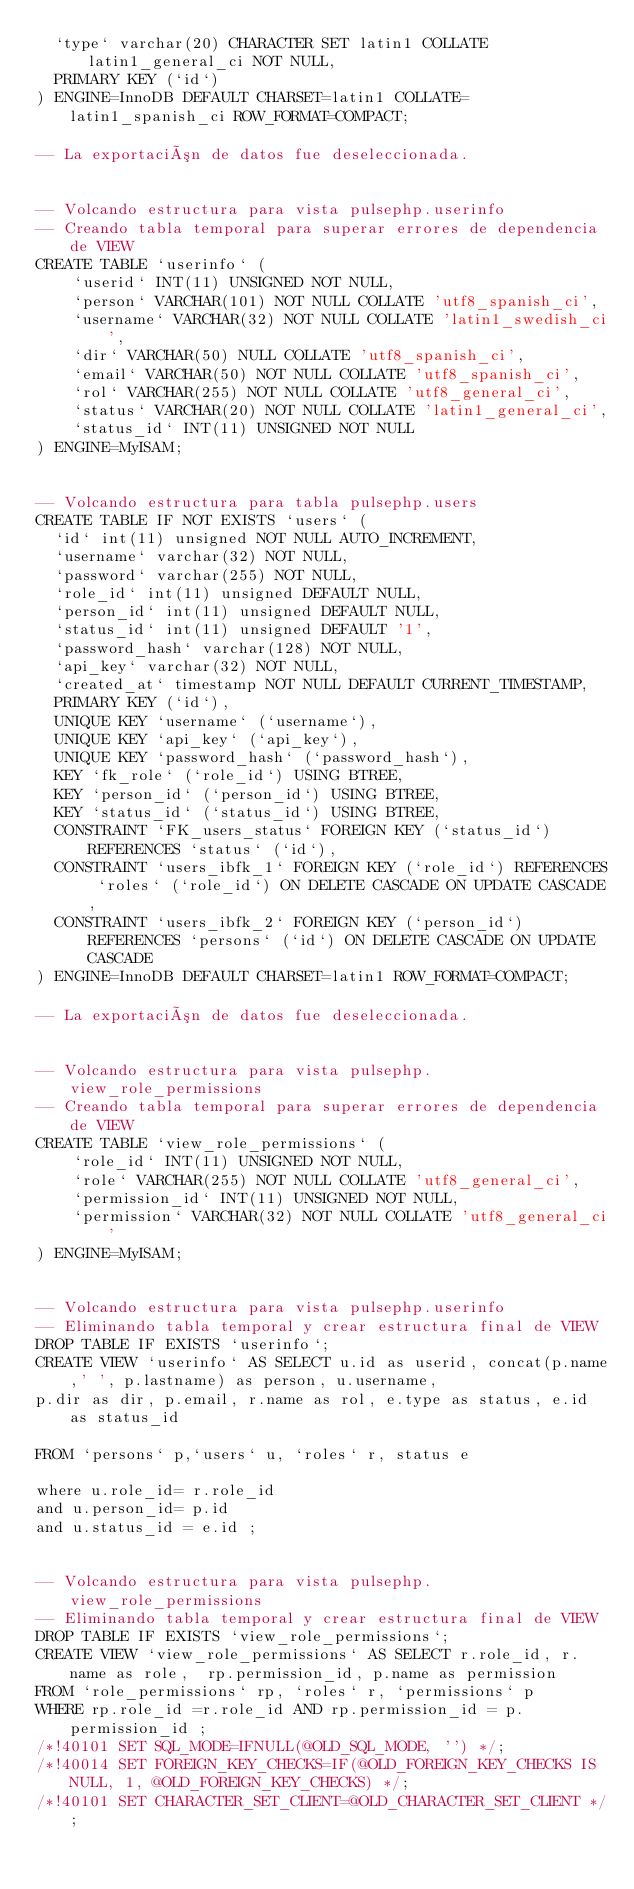Convert code to text. <code><loc_0><loc_0><loc_500><loc_500><_SQL_>  `type` varchar(20) CHARACTER SET latin1 COLLATE latin1_general_ci NOT NULL,
  PRIMARY KEY (`id`)
) ENGINE=InnoDB DEFAULT CHARSET=latin1 COLLATE=latin1_spanish_ci ROW_FORMAT=COMPACT;

-- La exportación de datos fue deseleccionada.


-- Volcando estructura para vista pulsephp.userinfo
-- Creando tabla temporal para superar errores de dependencia de VIEW
CREATE TABLE `userinfo` (
	`userid` INT(11) UNSIGNED NOT NULL,
	`person` VARCHAR(101) NOT NULL COLLATE 'utf8_spanish_ci',
	`username` VARCHAR(32) NOT NULL COLLATE 'latin1_swedish_ci',
	`dir` VARCHAR(50) NULL COLLATE 'utf8_spanish_ci',
	`email` VARCHAR(50) NOT NULL COLLATE 'utf8_spanish_ci',
	`rol` VARCHAR(255) NOT NULL COLLATE 'utf8_general_ci',
	`status` VARCHAR(20) NOT NULL COLLATE 'latin1_general_ci',
	`status_id` INT(11) UNSIGNED NOT NULL
) ENGINE=MyISAM;


-- Volcando estructura para tabla pulsephp.users
CREATE TABLE IF NOT EXISTS `users` (
  `id` int(11) unsigned NOT NULL AUTO_INCREMENT,
  `username` varchar(32) NOT NULL,
  `password` varchar(255) NOT NULL,
  `role_id` int(11) unsigned DEFAULT NULL,
  `person_id` int(11) unsigned DEFAULT NULL,
  `status_id` int(11) unsigned DEFAULT '1',
  `password_hash` varchar(128) NOT NULL,
  `api_key` varchar(32) NOT NULL,
  `created_at` timestamp NOT NULL DEFAULT CURRENT_TIMESTAMP,
  PRIMARY KEY (`id`),
  UNIQUE KEY `username` (`username`),
  UNIQUE KEY `api_key` (`api_key`),
  UNIQUE KEY `password_hash` (`password_hash`),
  KEY `fk_role` (`role_id`) USING BTREE,
  KEY `person_id` (`person_id`) USING BTREE,
  KEY `status_id` (`status_id`) USING BTREE,
  CONSTRAINT `FK_users_status` FOREIGN KEY (`status_id`) REFERENCES `status` (`id`),
  CONSTRAINT `users_ibfk_1` FOREIGN KEY (`role_id`) REFERENCES `roles` (`role_id`) ON DELETE CASCADE ON UPDATE CASCADE,
  CONSTRAINT `users_ibfk_2` FOREIGN KEY (`person_id`) REFERENCES `persons` (`id`) ON DELETE CASCADE ON UPDATE CASCADE
) ENGINE=InnoDB DEFAULT CHARSET=latin1 ROW_FORMAT=COMPACT;

-- La exportación de datos fue deseleccionada.


-- Volcando estructura para vista pulsephp.view_role_permissions
-- Creando tabla temporal para superar errores de dependencia de VIEW
CREATE TABLE `view_role_permissions` (
	`role_id` INT(11) UNSIGNED NOT NULL,
	`role` VARCHAR(255) NOT NULL COLLATE 'utf8_general_ci',
	`permission_id` INT(11) UNSIGNED NOT NULL,
	`permission` VARCHAR(32) NOT NULL COLLATE 'utf8_general_ci'
) ENGINE=MyISAM;


-- Volcando estructura para vista pulsephp.userinfo
-- Eliminando tabla temporal y crear estructura final de VIEW
DROP TABLE IF EXISTS `userinfo`;
CREATE VIEW `userinfo` AS SELECT u.id as userid, concat(p.name,' ', p.lastname) as person, u.username, 
p.dir as dir, p.email, r.name as rol, e.type as status, e.id as status_id

FROM `persons` p,`users` u, `roles` r, status e

where u.role_id= r.role_id
and u.person_id= p.id
and u.status_id = e.id ;


-- Volcando estructura para vista pulsephp.view_role_permissions
-- Eliminando tabla temporal y crear estructura final de VIEW
DROP TABLE IF EXISTS `view_role_permissions`;
CREATE VIEW `view_role_permissions` AS SELECT r.role_id, r.name as role,  rp.permission_id, p.name as permission  
FROM `role_permissions` rp, `roles` r, `permissions` p
WHERE rp.role_id =r.role_id AND rp.permission_id = p.permission_id ;
/*!40101 SET SQL_MODE=IFNULL(@OLD_SQL_MODE, '') */;
/*!40014 SET FOREIGN_KEY_CHECKS=IF(@OLD_FOREIGN_KEY_CHECKS IS NULL, 1, @OLD_FOREIGN_KEY_CHECKS) */;
/*!40101 SET CHARACTER_SET_CLIENT=@OLD_CHARACTER_SET_CLIENT */;
</code> 